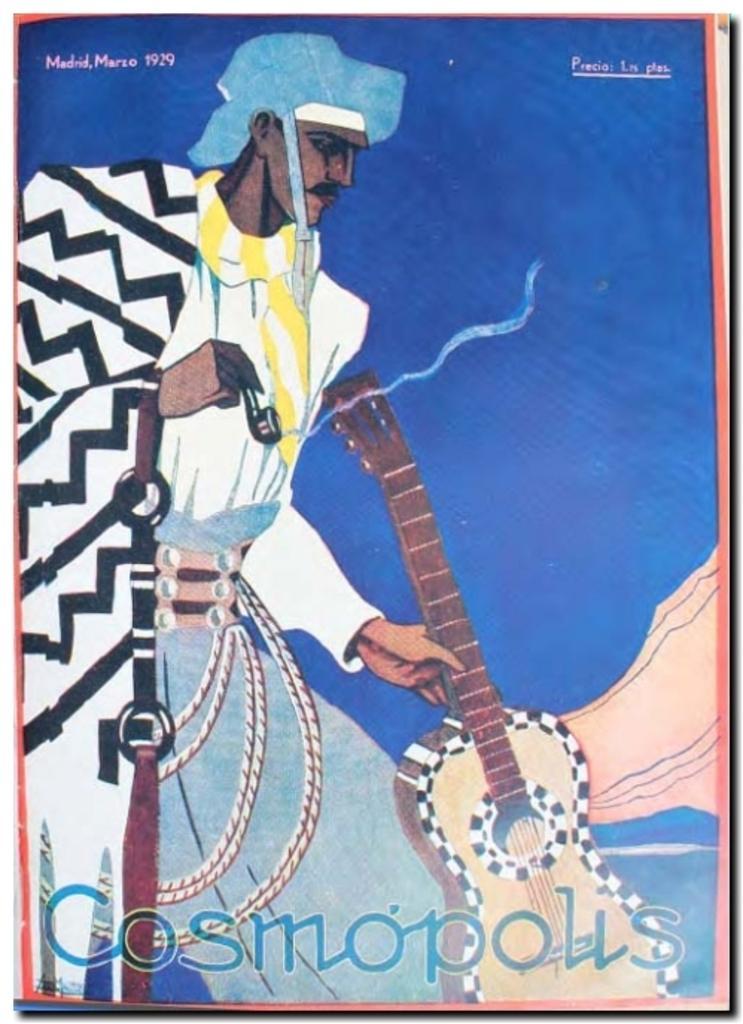Please provide a concise description of this image. In this image there is a painting of the person standing and holding a musical instrument. 